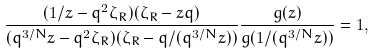<formula> <loc_0><loc_0><loc_500><loc_500>\frac { ( 1 / z - q ^ { 2 } \zeta _ { R } ) ( \zeta _ { R } - z q ) } { ( q ^ { 3 / N } z - q ^ { 2 } \zeta _ { R } ) ( \zeta _ { R } - q / ( q ^ { 3 / N } z ) ) } \frac { g ( z ) } { g ( 1 / ( q ^ { 3 / N } z ) ) } = 1 ,</formula> 